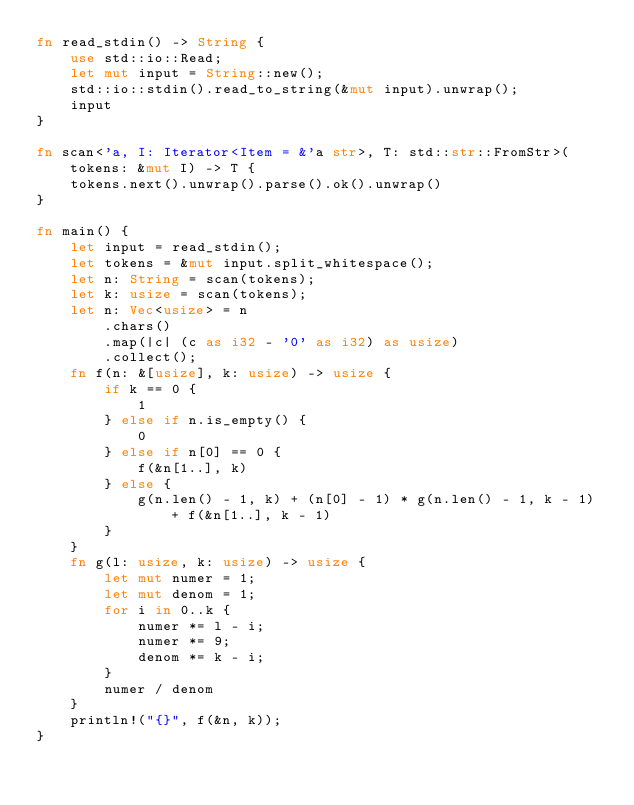<code> <loc_0><loc_0><loc_500><loc_500><_Rust_>fn read_stdin() -> String {
    use std::io::Read;
    let mut input = String::new();
    std::io::stdin().read_to_string(&mut input).unwrap();
    input
}

fn scan<'a, I: Iterator<Item = &'a str>, T: std::str::FromStr>(tokens: &mut I) -> T {
    tokens.next().unwrap().parse().ok().unwrap()
}

fn main() {
    let input = read_stdin();
    let tokens = &mut input.split_whitespace();
    let n: String = scan(tokens);
    let k: usize = scan(tokens);
    let n: Vec<usize> = n
        .chars()
        .map(|c| (c as i32 - '0' as i32) as usize)
        .collect();
    fn f(n: &[usize], k: usize) -> usize {
        if k == 0 {
            1
        } else if n.is_empty() {
            0
        } else if n[0] == 0 {
            f(&n[1..], k)
        } else {
            g(n.len() - 1, k) + (n[0] - 1) * g(n.len() - 1, k - 1) + f(&n[1..], k - 1)
        }
    }
    fn g(l: usize, k: usize) -> usize {
        let mut numer = 1;
        let mut denom = 1;
        for i in 0..k {
            numer *= l - i;
            numer *= 9;
            denom *= k - i;
        }
        numer / denom
    }
    println!("{}", f(&n, k));
}
</code> 